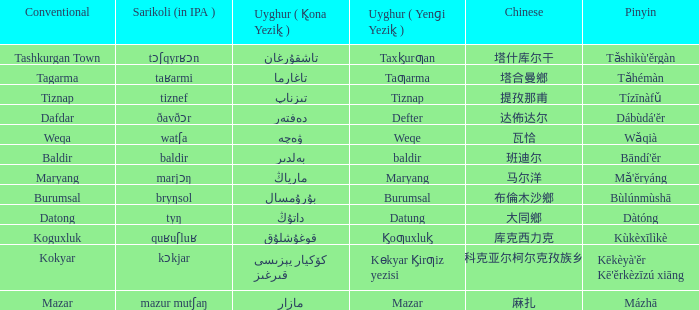Name the uyghur for  瓦恰 ۋەچە. 